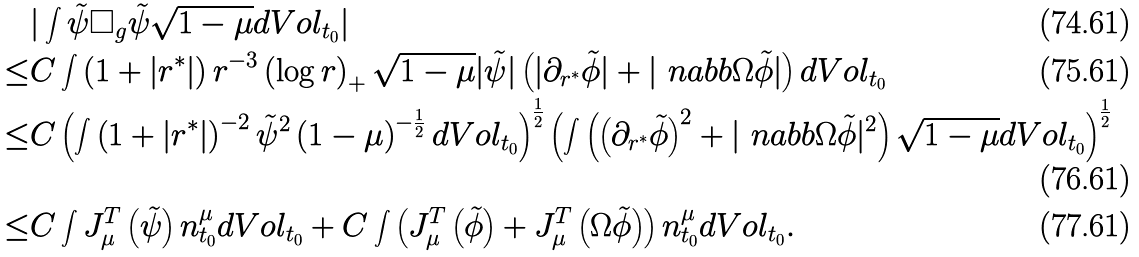Convert formula to latex. <formula><loc_0><loc_0><loc_500><loc_500>& | \int \tilde { \psi } \Box _ { g } \tilde { \psi } \sqrt { 1 - \mu } d V o l _ { t _ { 0 } } | \\ \leq & C \int \left ( 1 + | r ^ { * } | \right ) r ^ { - 3 } \left ( \log r \right ) _ { + } \sqrt { 1 - \mu } | \tilde { \psi } | \left ( | \partial _ { r ^ { * } } \tilde { \phi } | + | \ n a b b \Omega \tilde { \phi } | \right ) d V o l _ { t _ { 0 } } \\ \leq & C \left ( \int \left ( 1 + | r ^ { * } | \right ) ^ { - 2 } \tilde { \psi } ^ { 2 } \left ( 1 - \mu \right ) ^ { - \frac { 1 } { 2 } } d V o l _ { t _ { 0 } } \right ) ^ { \frac { 1 } { 2 } } \left ( \int \left ( \left ( \partial _ { r ^ { * } } \tilde { \phi } \right ) ^ { 2 } + | \ n a b b \Omega \tilde { \phi } | ^ { 2 } \right ) \sqrt { 1 - \mu } d V o l _ { t _ { 0 } } \right ) ^ { \frac { 1 } { 2 } } \\ \leq & C \int J ^ { T } _ { \mu } \left ( \tilde { \psi } \right ) n _ { t _ { 0 } } ^ { \mu } d V o l _ { t _ { 0 } } + C \int \left ( J ^ { T } _ { \mu } \left ( \tilde { \phi } \right ) + J ^ { T } _ { \mu } \left ( \Omega \tilde { \phi } \right ) \right ) n _ { t _ { 0 } } ^ { \mu } d V o l _ { t _ { 0 } } .</formula> 